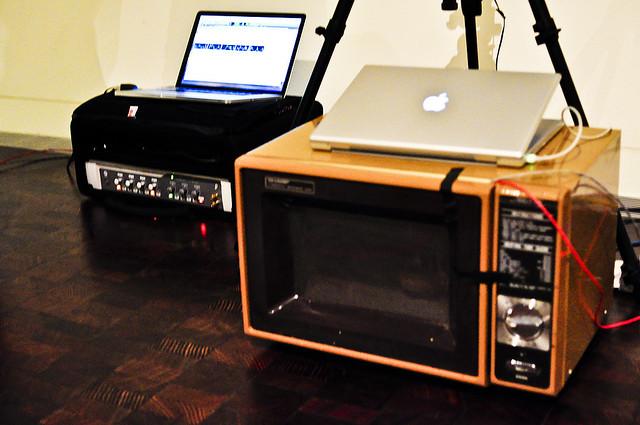What is the color of the wall?
Answer briefly. White. What brand of computer is the partially closed one?
Concise answer only. Apple. Is there a microwave in this picture?
Give a very brief answer. Yes. 